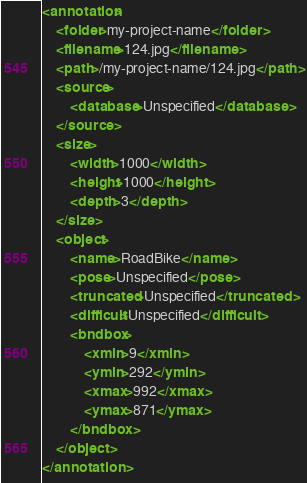Convert code to text. <code><loc_0><loc_0><loc_500><loc_500><_XML_><annotation>
	<folder>my-project-name</folder>
	<filename>124.jpg</filename>
	<path>/my-project-name/124.jpg</path>
	<source>
		<database>Unspecified</database>
	</source>
	<size>
		<width>1000</width>
		<height>1000</height>
		<depth>3</depth>
	</size>
	<object>
		<name>RoadBike</name>
		<pose>Unspecified</pose>
		<truncated>Unspecified</truncated>
		<difficult>Unspecified</difficult>
		<bndbox>
			<xmin>9</xmin>
			<ymin>292</ymin>
			<xmax>992</xmax>
			<ymax>871</ymax>
		</bndbox>
	</object>
</annotation></code> 